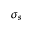<formula> <loc_0><loc_0><loc_500><loc_500>\sigma _ { s }</formula> 